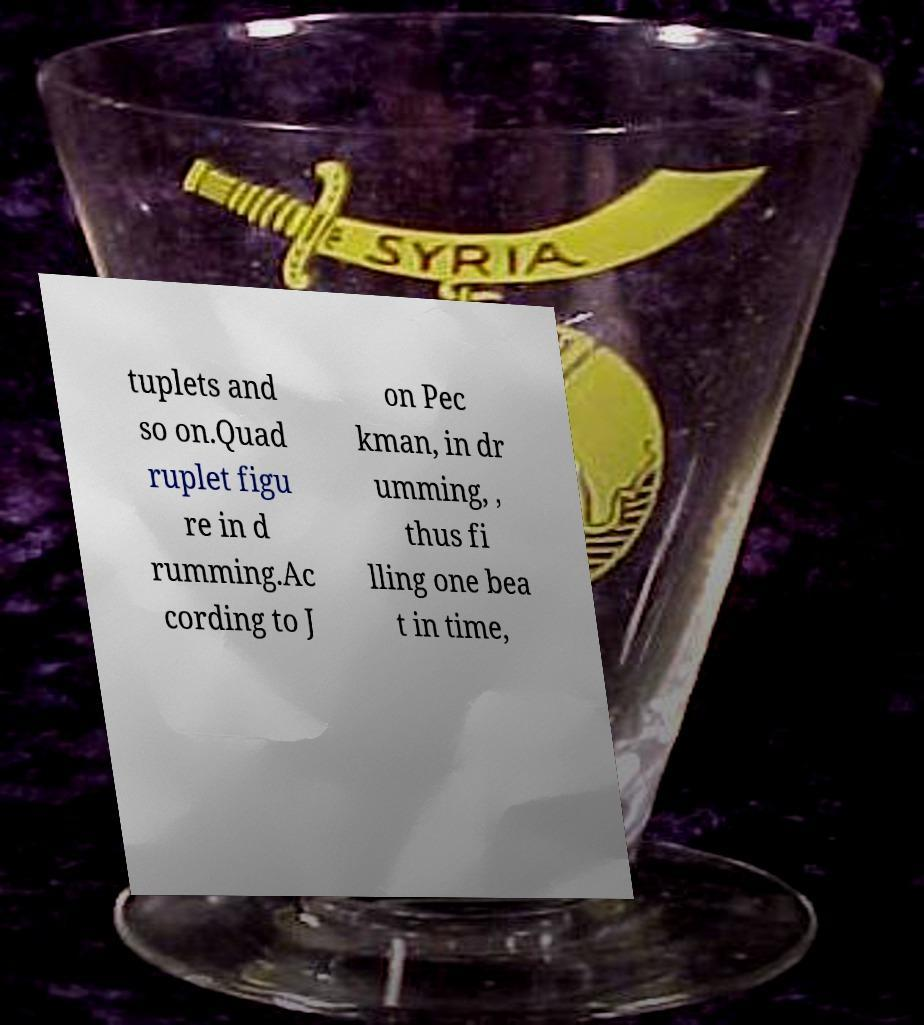Can you read and provide the text displayed in the image?This photo seems to have some interesting text. Can you extract and type it out for me? tuplets and so on.Quad ruplet figu re in d rumming.Ac cording to J on Pec kman, in dr umming, , thus fi lling one bea t in time, 